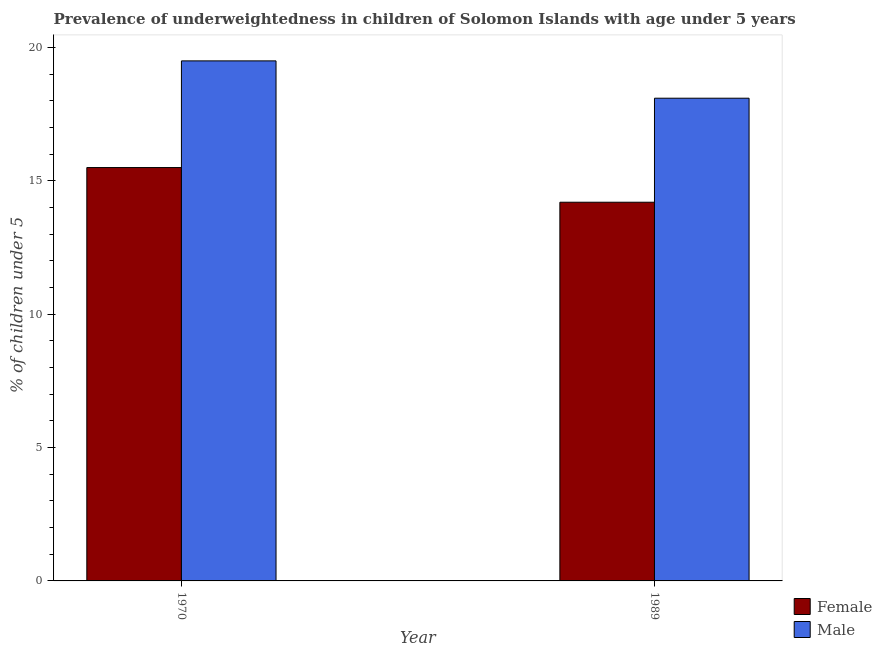How many different coloured bars are there?
Keep it short and to the point. 2. How many groups of bars are there?
Make the answer very short. 2. Are the number of bars per tick equal to the number of legend labels?
Provide a succinct answer. Yes. Are the number of bars on each tick of the X-axis equal?
Your response must be concise. Yes. How many bars are there on the 2nd tick from the right?
Your answer should be compact. 2. What is the label of the 2nd group of bars from the left?
Offer a terse response. 1989. What is the percentage of underweighted male children in 1989?
Offer a terse response. 18.1. Across all years, what is the maximum percentage of underweighted male children?
Give a very brief answer. 19.5. Across all years, what is the minimum percentage of underweighted female children?
Offer a very short reply. 14.2. What is the total percentage of underweighted male children in the graph?
Your answer should be very brief. 37.6. What is the difference between the percentage of underweighted female children in 1970 and that in 1989?
Your response must be concise. 1.3. What is the difference between the percentage of underweighted male children in 1989 and the percentage of underweighted female children in 1970?
Your answer should be compact. -1.4. What is the average percentage of underweighted female children per year?
Your response must be concise. 14.85. What is the ratio of the percentage of underweighted female children in 1970 to that in 1989?
Your answer should be compact. 1.09. What does the 2nd bar from the right in 1970 represents?
Give a very brief answer. Female. Are all the bars in the graph horizontal?
Give a very brief answer. No. Are the values on the major ticks of Y-axis written in scientific E-notation?
Provide a short and direct response. No. Does the graph contain any zero values?
Your answer should be very brief. No. How many legend labels are there?
Make the answer very short. 2. What is the title of the graph?
Make the answer very short. Prevalence of underweightedness in children of Solomon Islands with age under 5 years. Does "Taxes on profits and capital gains" appear as one of the legend labels in the graph?
Offer a very short reply. No. What is the label or title of the X-axis?
Make the answer very short. Year. What is the label or title of the Y-axis?
Keep it short and to the point.  % of children under 5. What is the  % of children under 5 of Male in 1970?
Provide a short and direct response. 19.5. What is the  % of children under 5 in Female in 1989?
Your response must be concise. 14.2. What is the  % of children under 5 in Male in 1989?
Your response must be concise. 18.1. Across all years, what is the maximum  % of children under 5 in Female?
Ensure brevity in your answer.  15.5. Across all years, what is the maximum  % of children under 5 of Male?
Your answer should be compact. 19.5. Across all years, what is the minimum  % of children under 5 in Female?
Provide a succinct answer. 14.2. Across all years, what is the minimum  % of children under 5 of Male?
Make the answer very short. 18.1. What is the total  % of children under 5 in Female in the graph?
Your answer should be very brief. 29.7. What is the total  % of children under 5 of Male in the graph?
Your response must be concise. 37.6. What is the difference between the  % of children under 5 of Female in 1970 and that in 1989?
Give a very brief answer. 1.3. What is the difference between the  % of children under 5 of Male in 1970 and that in 1989?
Your answer should be compact. 1.4. What is the difference between the  % of children under 5 of Female in 1970 and the  % of children under 5 of Male in 1989?
Offer a terse response. -2.6. What is the average  % of children under 5 of Female per year?
Make the answer very short. 14.85. What is the average  % of children under 5 of Male per year?
Provide a succinct answer. 18.8. What is the ratio of the  % of children under 5 in Female in 1970 to that in 1989?
Ensure brevity in your answer.  1.09. What is the ratio of the  % of children under 5 in Male in 1970 to that in 1989?
Your response must be concise. 1.08. What is the difference between the highest and the second highest  % of children under 5 of Male?
Give a very brief answer. 1.4. What is the difference between the highest and the lowest  % of children under 5 of Female?
Give a very brief answer. 1.3. What is the difference between the highest and the lowest  % of children under 5 of Male?
Offer a very short reply. 1.4. 